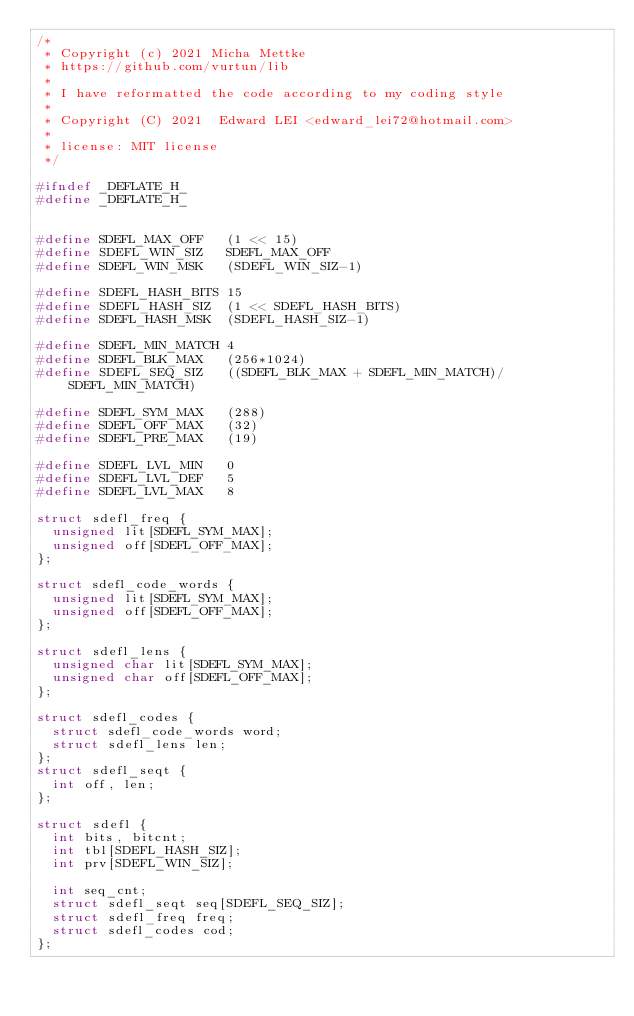Convert code to text. <code><loc_0><loc_0><loc_500><loc_500><_C_>/*
 * Copyright (c) 2021 Micha Mettke
 * https://github.com/vurtun/lib
 *
 * I have reformatted the code according to my coding style
 *
 * Copyright (C) 2021  Edward LEI <edward_lei72@hotmail.com>
 *
 * license: MIT license
 */

#ifndef _DEFLATE_H_
#define _DEFLATE_H_


#define SDEFL_MAX_OFF   (1 << 15)
#define SDEFL_WIN_SIZ   SDEFL_MAX_OFF
#define SDEFL_WIN_MSK   (SDEFL_WIN_SIZ-1)

#define SDEFL_HASH_BITS 15
#define SDEFL_HASH_SIZ  (1 << SDEFL_HASH_BITS)
#define SDEFL_HASH_MSK  (SDEFL_HASH_SIZ-1)

#define SDEFL_MIN_MATCH 4
#define SDEFL_BLK_MAX   (256*1024)
#define SDEFL_SEQ_SIZ   ((SDEFL_BLK_MAX + SDEFL_MIN_MATCH)/SDEFL_MIN_MATCH)

#define SDEFL_SYM_MAX   (288)
#define SDEFL_OFF_MAX   (32)
#define SDEFL_PRE_MAX   (19)

#define SDEFL_LVL_MIN   0
#define SDEFL_LVL_DEF   5
#define SDEFL_LVL_MAX   8

struct sdefl_freq {
  unsigned lit[SDEFL_SYM_MAX];
  unsigned off[SDEFL_OFF_MAX];
};

struct sdefl_code_words {
  unsigned lit[SDEFL_SYM_MAX];
  unsigned off[SDEFL_OFF_MAX];
};

struct sdefl_lens {
  unsigned char lit[SDEFL_SYM_MAX];
  unsigned char off[SDEFL_OFF_MAX];
};

struct sdefl_codes {
  struct sdefl_code_words word;
  struct sdefl_lens len;
};
struct sdefl_seqt {
  int off, len;
};

struct sdefl {
  int bits, bitcnt;
  int tbl[SDEFL_HASH_SIZ];
  int prv[SDEFL_WIN_SIZ];

  int seq_cnt;
  struct sdefl_seqt seq[SDEFL_SEQ_SIZ];
  struct sdefl_freq freq;
  struct sdefl_codes cod;
};

</code> 